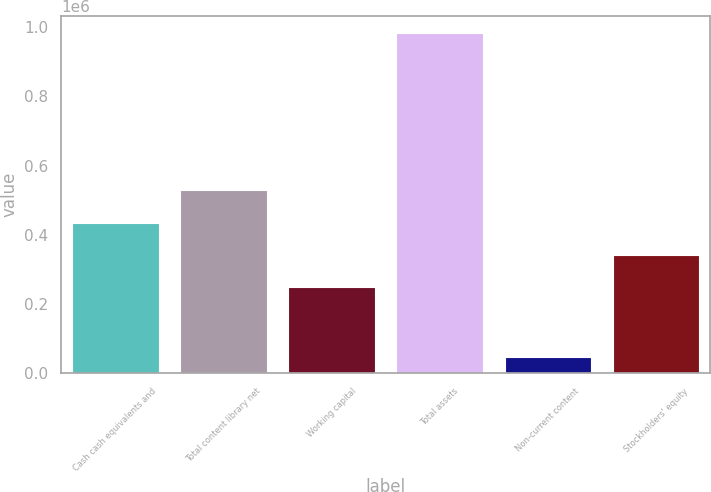Convert chart. <chart><loc_0><loc_0><loc_500><loc_500><bar_chart><fcel>Cash cash equivalents and<fcel>Total content library net<fcel>Working capital<fcel>Total assets<fcel>Non-current content<fcel>Stockholders' equity<nl><fcel>435430<fcel>528818<fcel>248652<fcel>982067<fcel>48179<fcel>342041<nl></chart> 